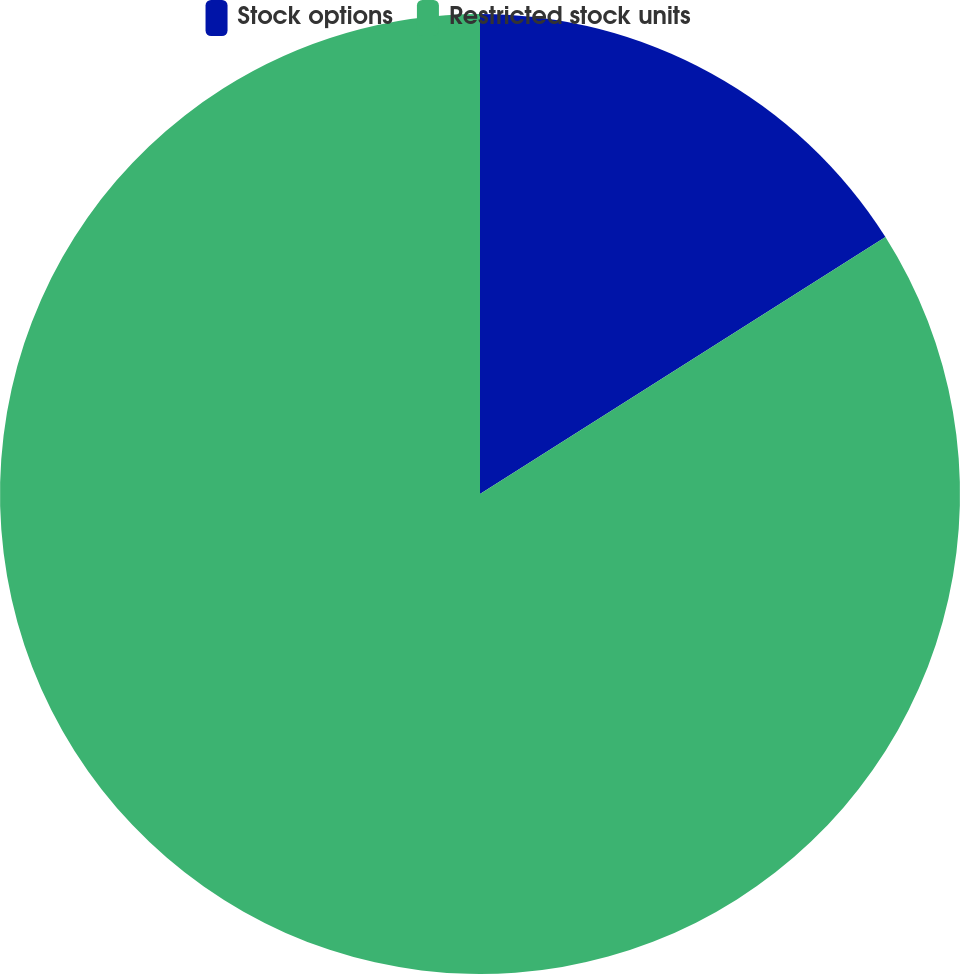<chart> <loc_0><loc_0><loc_500><loc_500><pie_chart><fcel>Stock options<fcel>Restricted stock units<nl><fcel>16.01%<fcel>83.99%<nl></chart> 